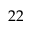<formula> <loc_0><loc_0><loc_500><loc_500>2 2</formula> 